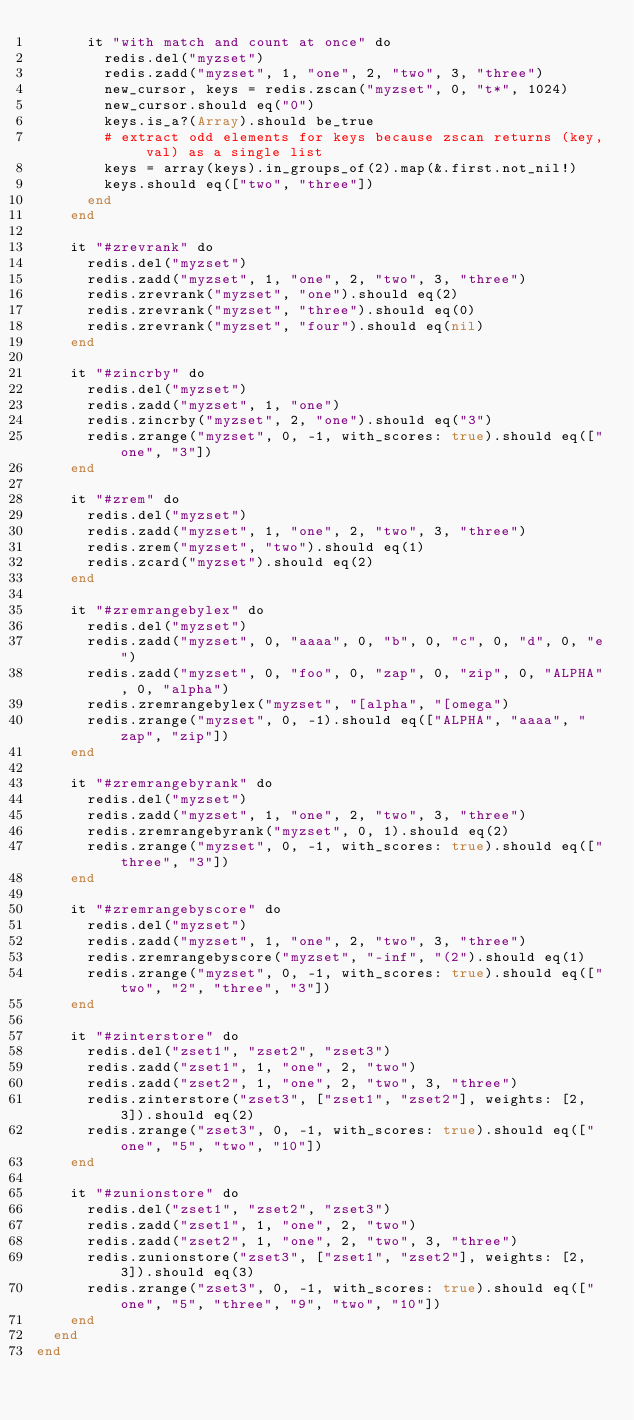Convert code to text. <code><loc_0><loc_0><loc_500><loc_500><_Crystal_>      it "with match and count at once" do
        redis.del("myzset")
        redis.zadd("myzset", 1, "one", 2, "two", 3, "three")
        new_cursor, keys = redis.zscan("myzset", 0, "t*", 1024)
        new_cursor.should eq("0")
        keys.is_a?(Array).should be_true
        # extract odd elements for keys because zscan returns (key, val) as a single list
        keys = array(keys).in_groups_of(2).map(&.first.not_nil!)
        keys.should eq(["two", "three"])
      end
    end

    it "#zrevrank" do
      redis.del("myzset")
      redis.zadd("myzset", 1, "one", 2, "two", 3, "three")
      redis.zrevrank("myzset", "one").should eq(2)
      redis.zrevrank("myzset", "three").should eq(0)
      redis.zrevrank("myzset", "four").should eq(nil)
    end

    it "#zincrby" do
      redis.del("myzset")
      redis.zadd("myzset", 1, "one")
      redis.zincrby("myzset", 2, "one").should eq("3")
      redis.zrange("myzset", 0, -1, with_scores: true).should eq(["one", "3"])
    end

    it "#zrem" do
      redis.del("myzset")
      redis.zadd("myzset", 1, "one", 2, "two", 3, "three")
      redis.zrem("myzset", "two").should eq(1)
      redis.zcard("myzset").should eq(2)
    end

    it "#zremrangebylex" do
      redis.del("myzset")
      redis.zadd("myzset", 0, "aaaa", 0, "b", 0, "c", 0, "d", 0, "e")
      redis.zadd("myzset", 0, "foo", 0, "zap", 0, "zip", 0, "ALPHA", 0, "alpha")
      redis.zremrangebylex("myzset", "[alpha", "[omega")
      redis.zrange("myzset", 0, -1).should eq(["ALPHA", "aaaa", "zap", "zip"])
    end

    it "#zremrangebyrank" do
      redis.del("myzset")
      redis.zadd("myzset", 1, "one", 2, "two", 3, "three")
      redis.zremrangebyrank("myzset", 0, 1).should eq(2)
      redis.zrange("myzset", 0, -1, with_scores: true).should eq(["three", "3"])
    end

    it "#zremrangebyscore" do
      redis.del("myzset")
      redis.zadd("myzset", 1, "one", 2, "two", 3, "three")
      redis.zremrangebyscore("myzset", "-inf", "(2").should eq(1)
      redis.zrange("myzset", 0, -1, with_scores: true).should eq(["two", "2", "three", "3"])
    end

    it "#zinterstore" do
      redis.del("zset1", "zset2", "zset3")
      redis.zadd("zset1", 1, "one", 2, "two")
      redis.zadd("zset2", 1, "one", 2, "two", 3, "three")
      redis.zinterstore("zset3", ["zset1", "zset2"], weights: [2, 3]).should eq(2)
      redis.zrange("zset3", 0, -1, with_scores: true).should eq(["one", "5", "two", "10"])
    end

    it "#zunionstore" do
      redis.del("zset1", "zset2", "zset3")
      redis.zadd("zset1", 1, "one", 2, "two")
      redis.zadd("zset2", 1, "one", 2, "two", 3, "three")
      redis.zunionstore("zset3", ["zset1", "zset2"], weights: [2, 3]).should eq(3)
      redis.zrange("zset3", 0, -1, with_scores: true).should eq(["one", "5", "three", "9", "two", "10"])
    end
  end
end
</code> 